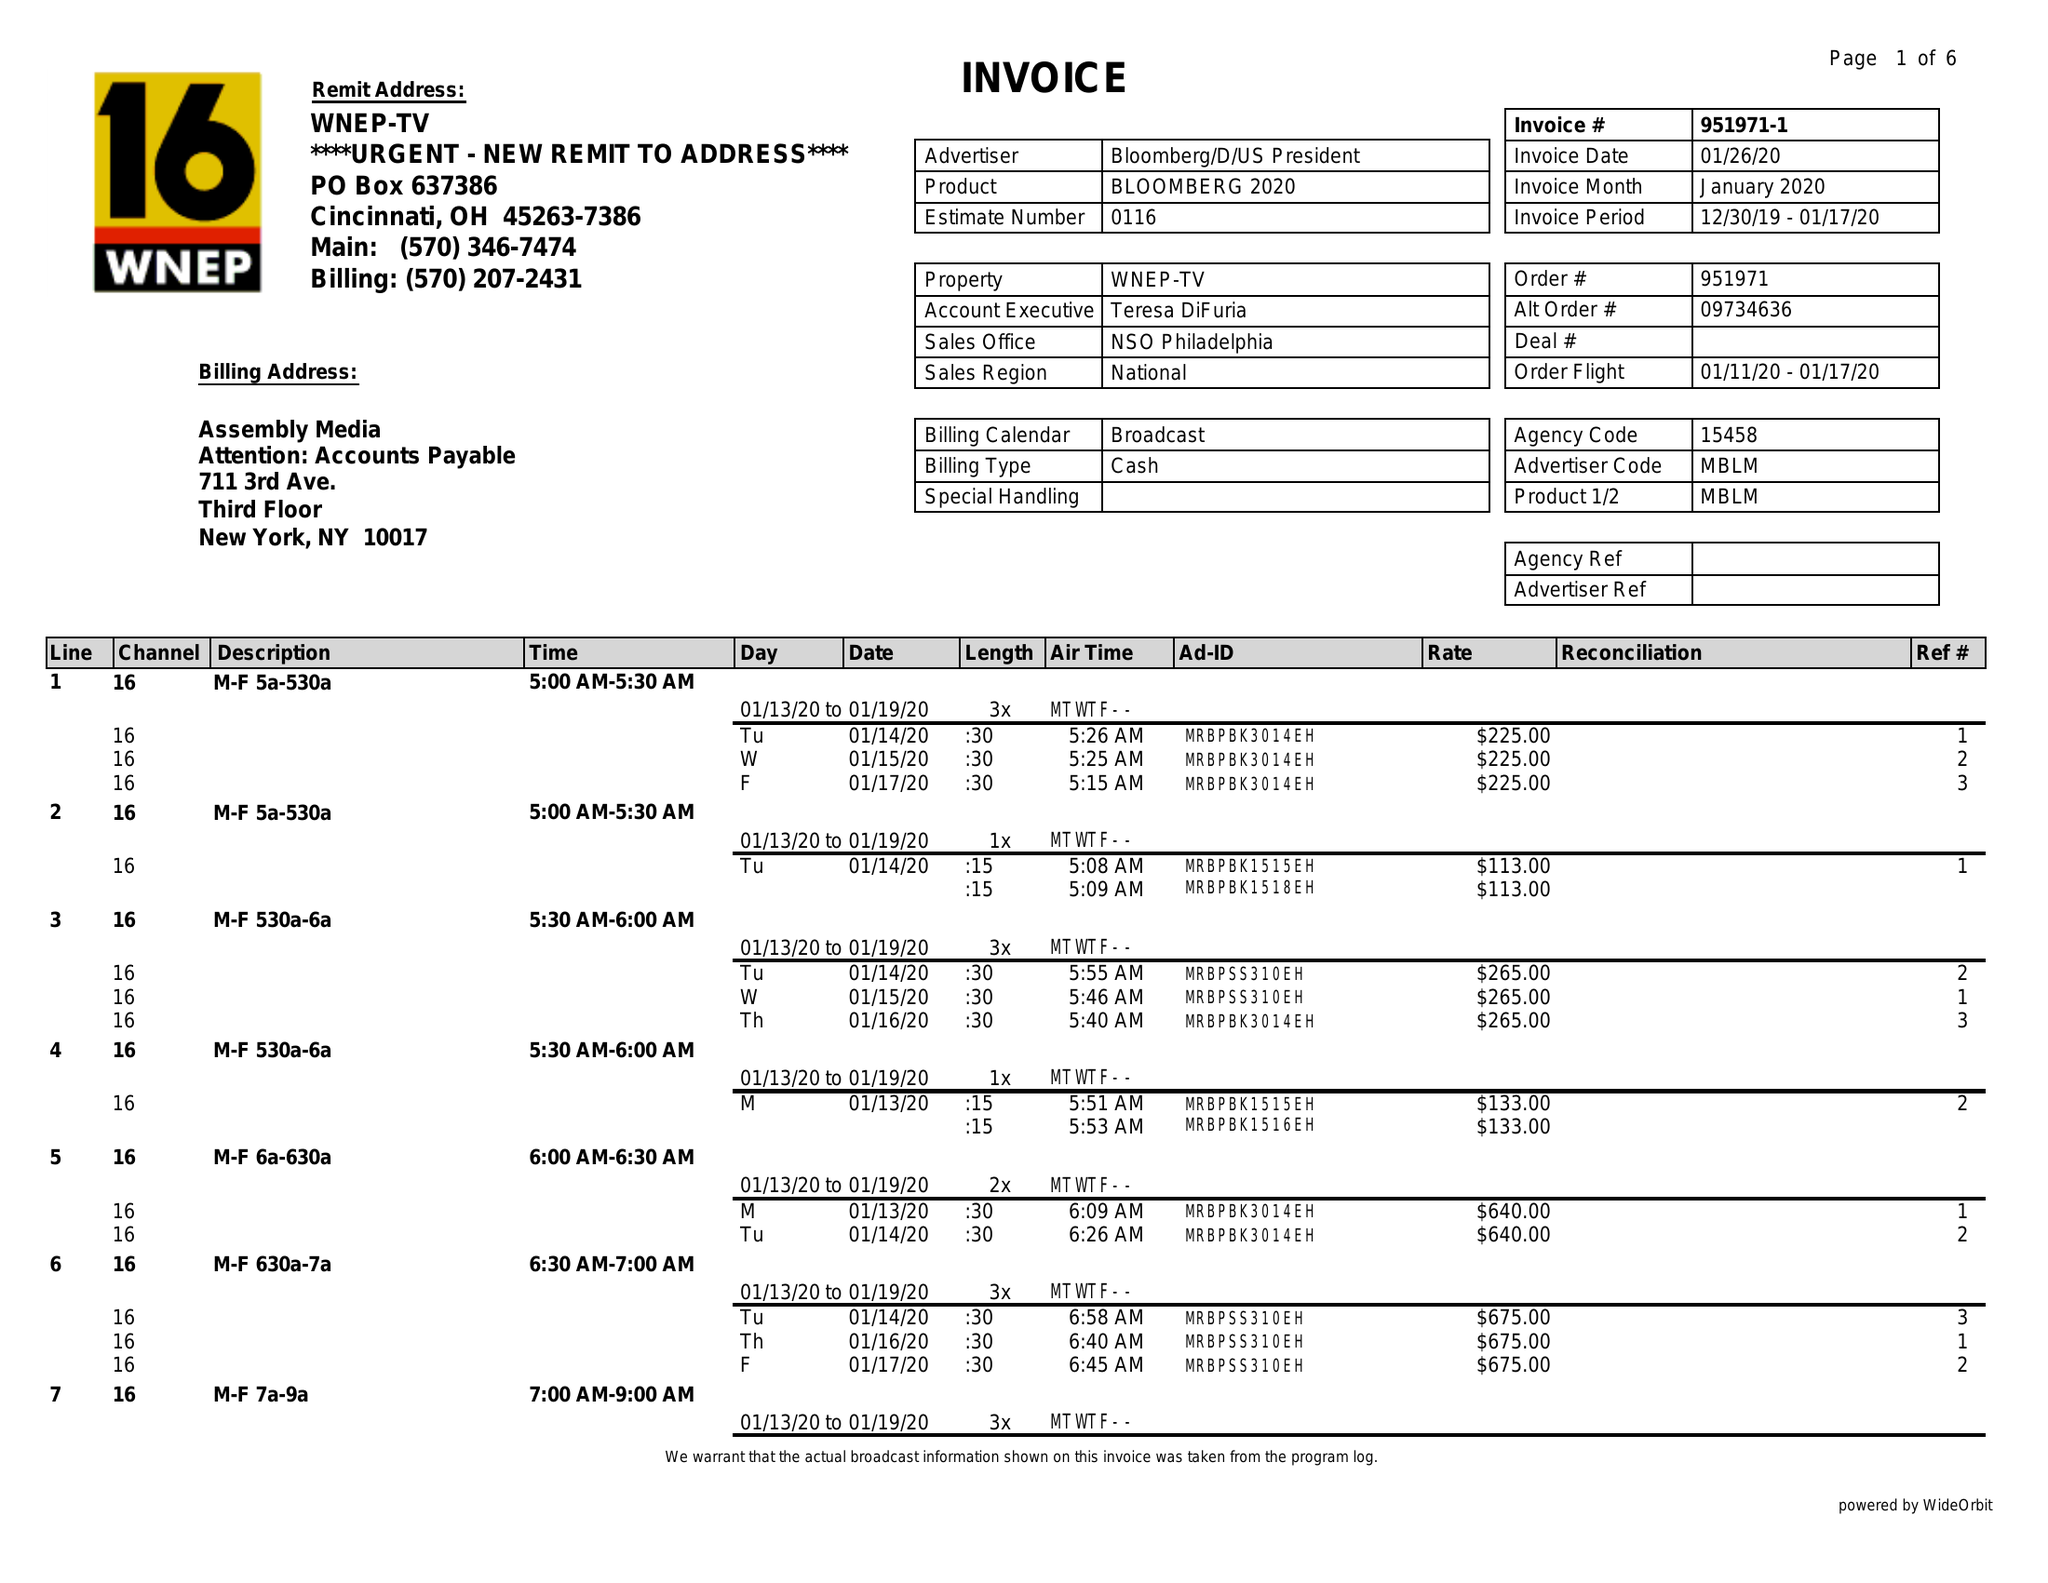What is the value for the flight_to?
Answer the question using a single word or phrase. 01/17/20 